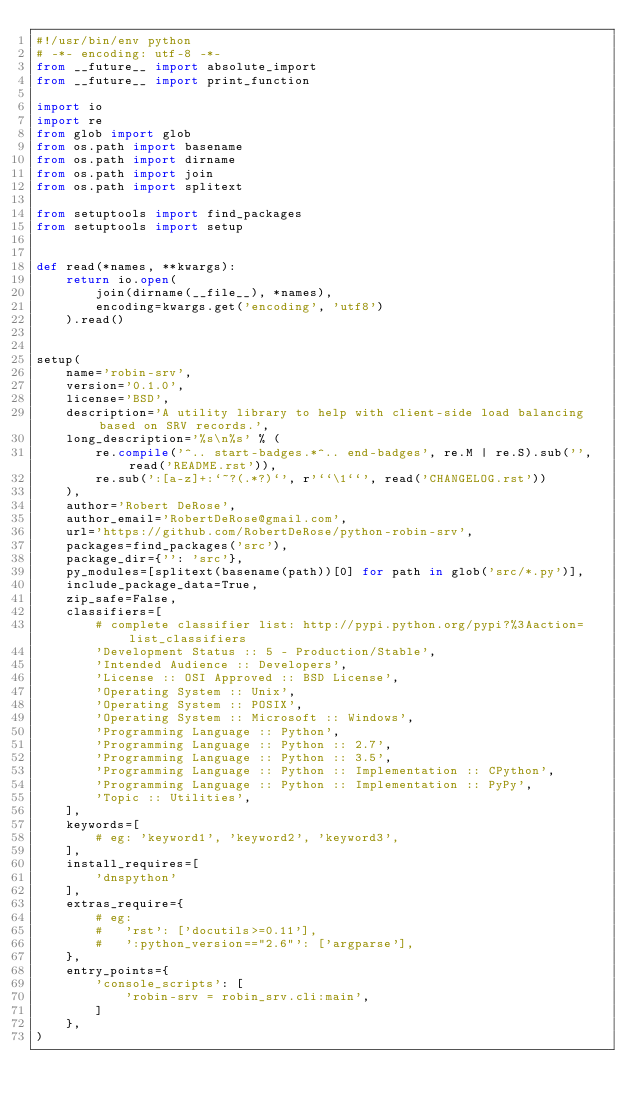<code> <loc_0><loc_0><loc_500><loc_500><_Python_>#!/usr/bin/env python
# -*- encoding: utf-8 -*-
from __future__ import absolute_import
from __future__ import print_function

import io
import re
from glob import glob
from os.path import basename
from os.path import dirname
from os.path import join
from os.path import splitext

from setuptools import find_packages
from setuptools import setup


def read(*names, **kwargs):
    return io.open(
        join(dirname(__file__), *names),
        encoding=kwargs.get('encoding', 'utf8')
    ).read()


setup(
    name='robin-srv',
    version='0.1.0',
    license='BSD',
    description='A utility library to help with client-side load balancing based on SRV records.',
    long_description='%s\n%s' % (
        re.compile('^.. start-badges.*^.. end-badges', re.M | re.S).sub('', read('README.rst')),
        re.sub(':[a-z]+:`~?(.*?)`', r'``\1``', read('CHANGELOG.rst'))
    ),
    author='Robert DeRose',
    author_email='RobertDeRose@gmail.com',
    url='https://github.com/RobertDeRose/python-robin-srv',
    packages=find_packages('src'),
    package_dir={'': 'src'},
    py_modules=[splitext(basename(path))[0] for path in glob('src/*.py')],
    include_package_data=True,
    zip_safe=False,
    classifiers=[
        # complete classifier list: http://pypi.python.org/pypi?%3Aaction=list_classifiers
        'Development Status :: 5 - Production/Stable',
        'Intended Audience :: Developers',
        'License :: OSI Approved :: BSD License',
        'Operating System :: Unix',
        'Operating System :: POSIX',
        'Operating System :: Microsoft :: Windows',
        'Programming Language :: Python',
        'Programming Language :: Python :: 2.7',
        'Programming Language :: Python :: 3.5',
        'Programming Language :: Python :: Implementation :: CPython',
        'Programming Language :: Python :: Implementation :: PyPy',
        'Topic :: Utilities',
    ],
    keywords=[
        # eg: 'keyword1', 'keyword2', 'keyword3',
    ],
    install_requires=[
        'dnspython'
    ],
    extras_require={
        # eg:
        #   'rst': ['docutils>=0.11'],
        #   ':python_version=="2.6"': ['argparse'],
    },
    entry_points={
        'console_scripts': [
            'robin-srv = robin_srv.cli:main',
        ]
    },
)
</code> 